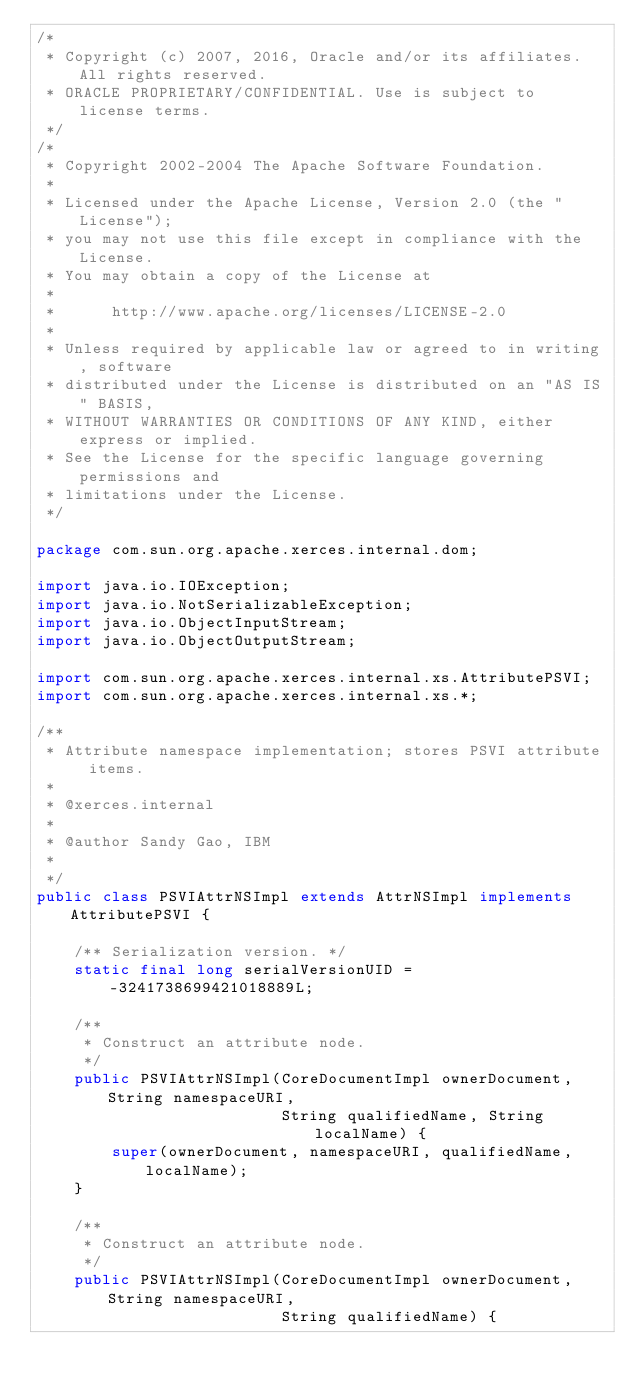<code> <loc_0><loc_0><loc_500><loc_500><_Java_>/*
 * Copyright (c) 2007, 2016, Oracle and/or its affiliates. All rights reserved.
 * ORACLE PROPRIETARY/CONFIDENTIAL. Use is subject to license terms.
 */
/*
 * Copyright 2002-2004 The Apache Software Foundation.
 *
 * Licensed under the Apache License, Version 2.0 (the "License");
 * you may not use this file except in compliance with the License.
 * You may obtain a copy of the License at
 *
 *      http://www.apache.org/licenses/LICENSE-2.0
 *
 * Unless required by applicable law or agreed to in writing, software
 * distributed under the License is distributed on an "AS IS" BASIS,
 * WITHOUT WARRANTIES OR CONDITIONS OF ANY KIND, either express or implied.
 * See the License for the specific language governing permissions and
 * limitations under the License.
 */

package com.sun.org.apache.xerces.internal.dom;

import java.io.IOException;
import java.io.NotSerializableException;
import java.io.ObjectInputStream;
import java.io.ObjectOutputStream;

import com.sun.org.apache.xerces.internal.xs.AttributePSVI;
import com.sun.org.apache.xerces.internal.xs.*;

/**
 * Attribute namespace implementation; stores PSVI attribute items.
 *
 * @xerces.internal
 *
 * @author Sandy Gao, IBM
 *
 */
public class PSVIAttrNSImpl extends AttrNSImpl implements AttributePSVI {

    /** Serialization version. */
    static final long serialVersionUID = -3241738699421018889L;

    /**
     * Construct an attribute node.
     */
    public PSVIAttrNSImpl(CoreDocumentImpl ownerDocument, String namespaceURI,
                          String qualifiedName, String localName) {
        super(ownerDocument, namespaceURI, qualifiedName, localName);
    }

    /**
     * Construct an attribute node.
     */
    public PSVIAttrNSImpl(CoreDocumentImpl ownerDocument, String namespaceURI,
                          String qualifiedName) {</code> 